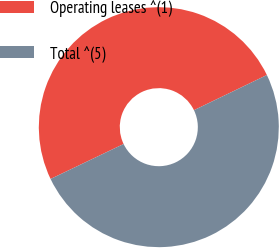Convert chart to OTSL. <chart><loc_0><loc_0><loc_500><loc_500><pie_chart><fcel>Operating leases ^(1)<fcel>Total ^(5)<nl><fcel>49.95%<fcel>50.05%<nl></chart> 